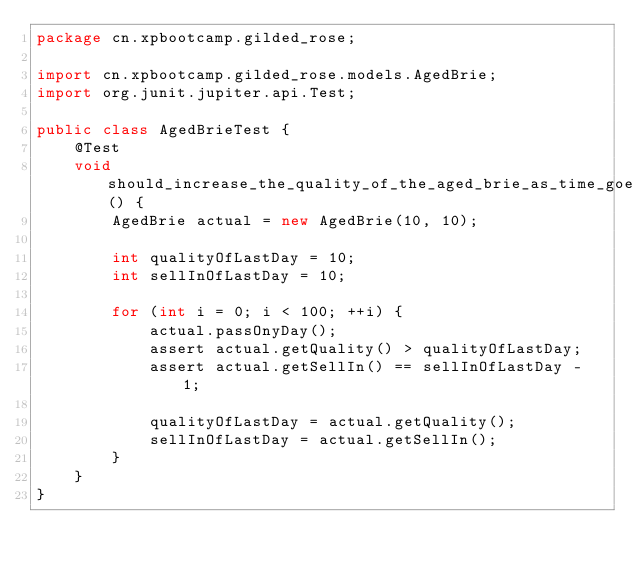Convert code to text. <code><loc_0><loc_0><loc_500><loc_500><_Java_>package cn.xpbootcamp.gilded_rose;

import cn.xpbootcamp.gilded_rose.models.AgedBrie;
import org.junit.jupiter.api.Test;

public class AgedBrieTest {
    @Test
    void should_increase_the_quality_of_the_aged_brie_as_time_goes() {
        AgedBrie actual = new AgedBrie(10, 10);

        int qualityOfLastDay = 10;
        int sellInOfLastDay = 10;

        for (int i = 0; i < 100; ++i) {
            actual.passOnyDay();
            assert actual.getQuality() > qualityOfLastDay;
            assert actual.getSellIn() == sellInOfLastDay - 1;

            qualityOfLastDay = actual.getQuality();
            sellInOfLastDay = actual.getSellIn();
        }
    }
}
</code> 